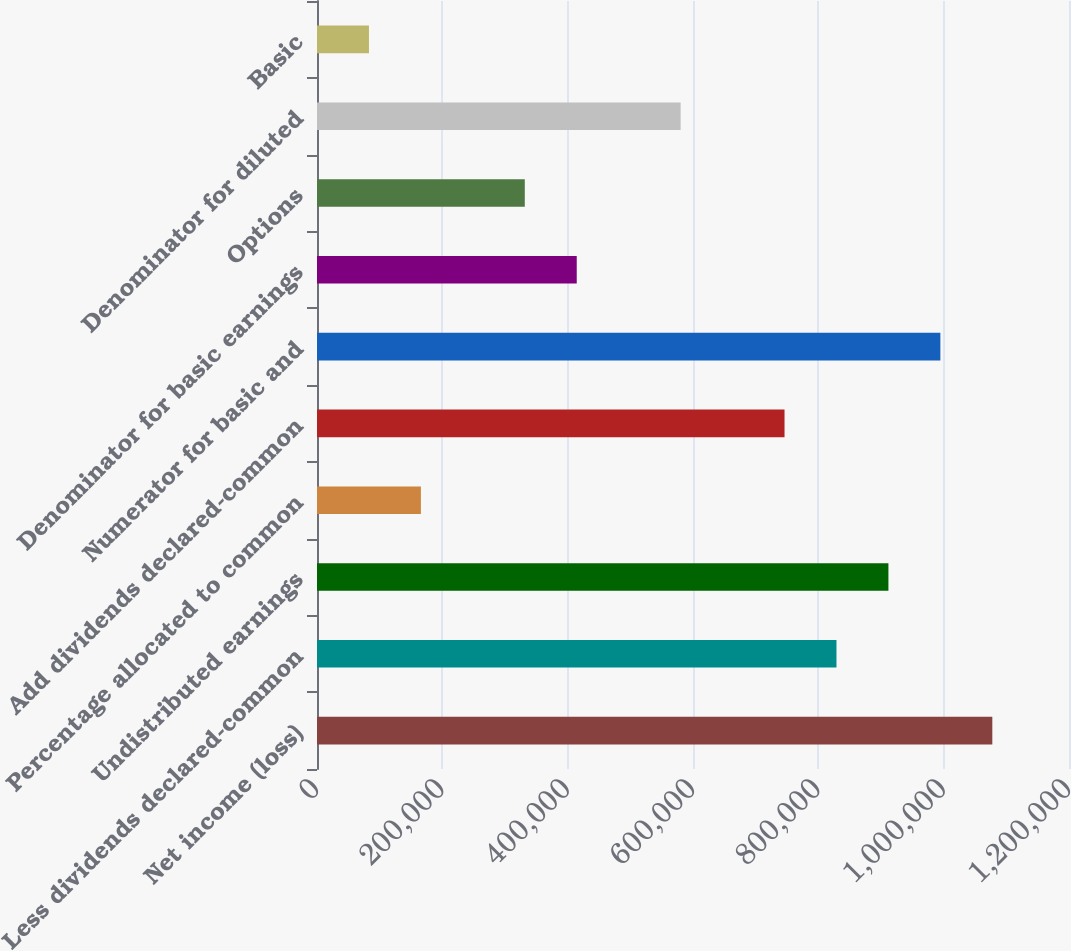Convert chart to OTSL. <chart><loc_0><loc_0><loc_500><loc_500><bar_chart><fcel>Net income (loss)<fcel>Less dividends declared-common<fcel>Undistributed earnings<fcel>Percentage allocated to common<fcel>Add dividends declared-common<fcel>Numerator for basic and<fcel>Denominator for basic earnings<fcel>Options<fcel>Denominator for diluted<fcel>Basic<nl><fcel>1.07764e+06<fcel>828954<fcel>911848<fcel>165803<fcel>746060<fcel>994742<fcel>414485<fcel>331591<fcel>580273<fcel>82909.6<nl></chart> 